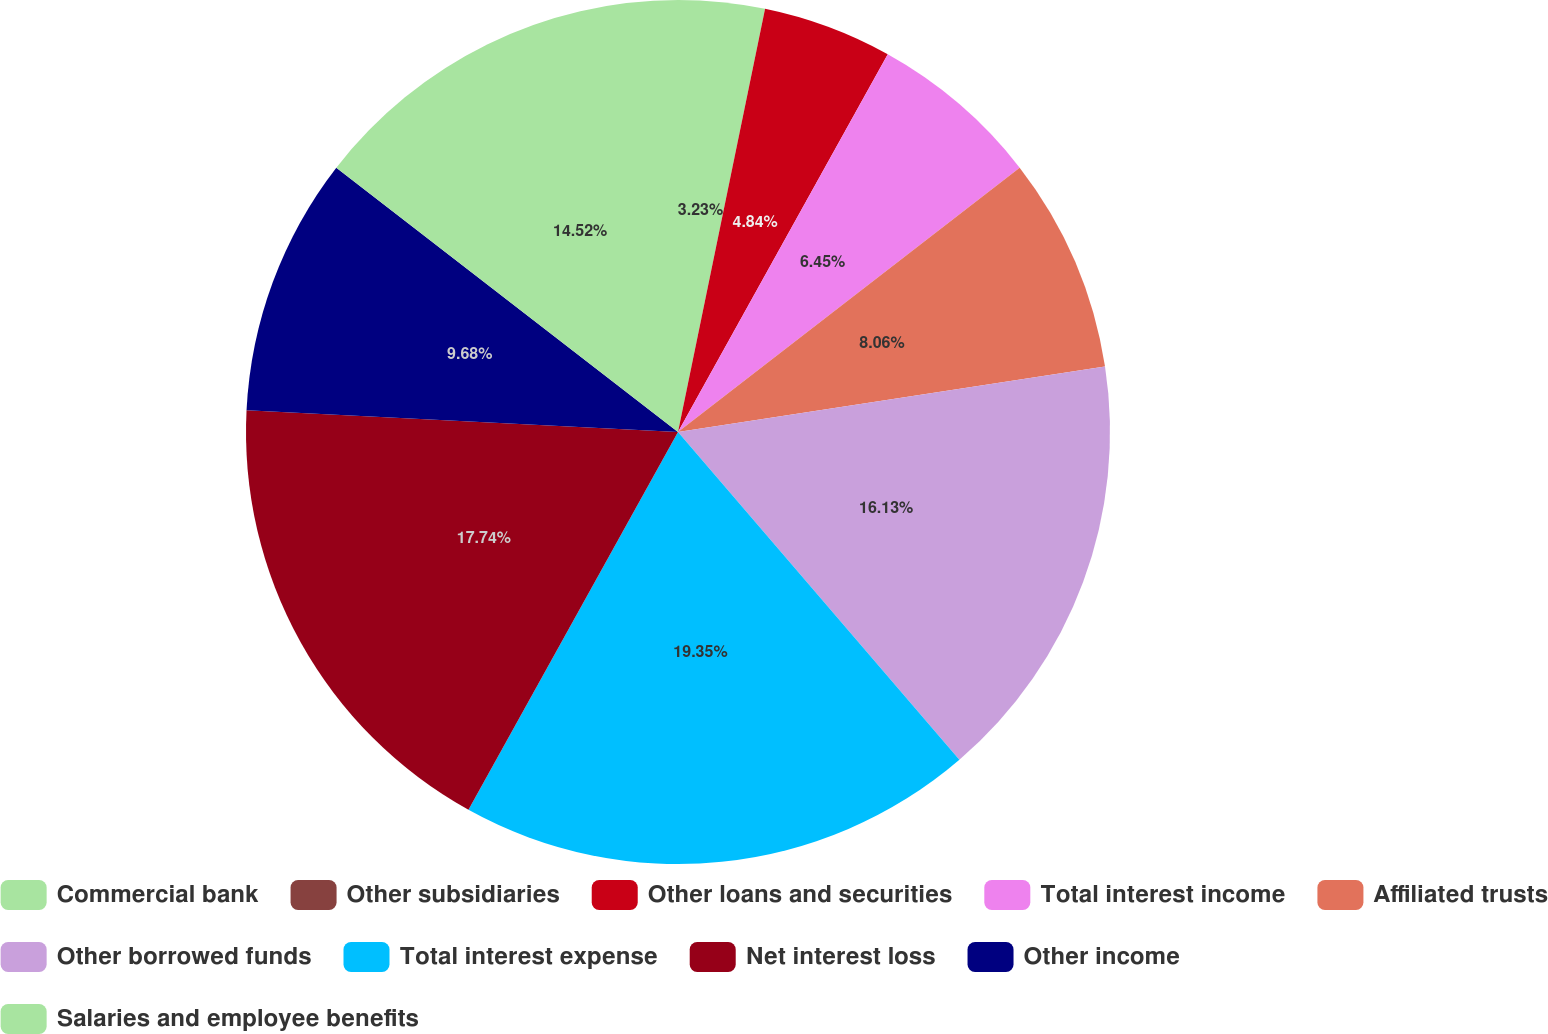Convert chart. <chart><loc_0><loc_0><loc_500><loc_500><pie_chart><fcel>Commercial bank<fcel>Other subsidiaries<fcel>Other loans and securities<fcel>Total interest income<fcel>Affiliated trusts<fcel>Other borrowed funds<fcel>Total interest expense<fcel>Net interest loss<fcel>Other income<fcel>Salaries and employee benefits<nl><fcel>3.23%<fcel>0.0%<fcel>4.84%<fcel>6.45%<fcel>8.06%<fcel>16.13%<fcel>19.35%<fcel>17.74%<fcel>9.68%<fcel>14.52%<nl></chart> 